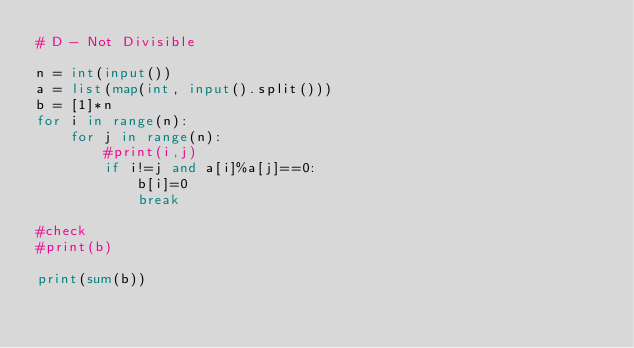<code> <loc_0><loc_0><loc_500><loc_500><_Python_># D - Not Divisible

n = int(input())
a = list(map(int, input().split()))
b = [1]*n
for i in range(n):
    for j in range(n):
        #print(i,j)
        if i!=j and a[i]%a[j]==0:
            b[i]=0
            break

#check
#print(b)

print(sum(b))
        </code> 